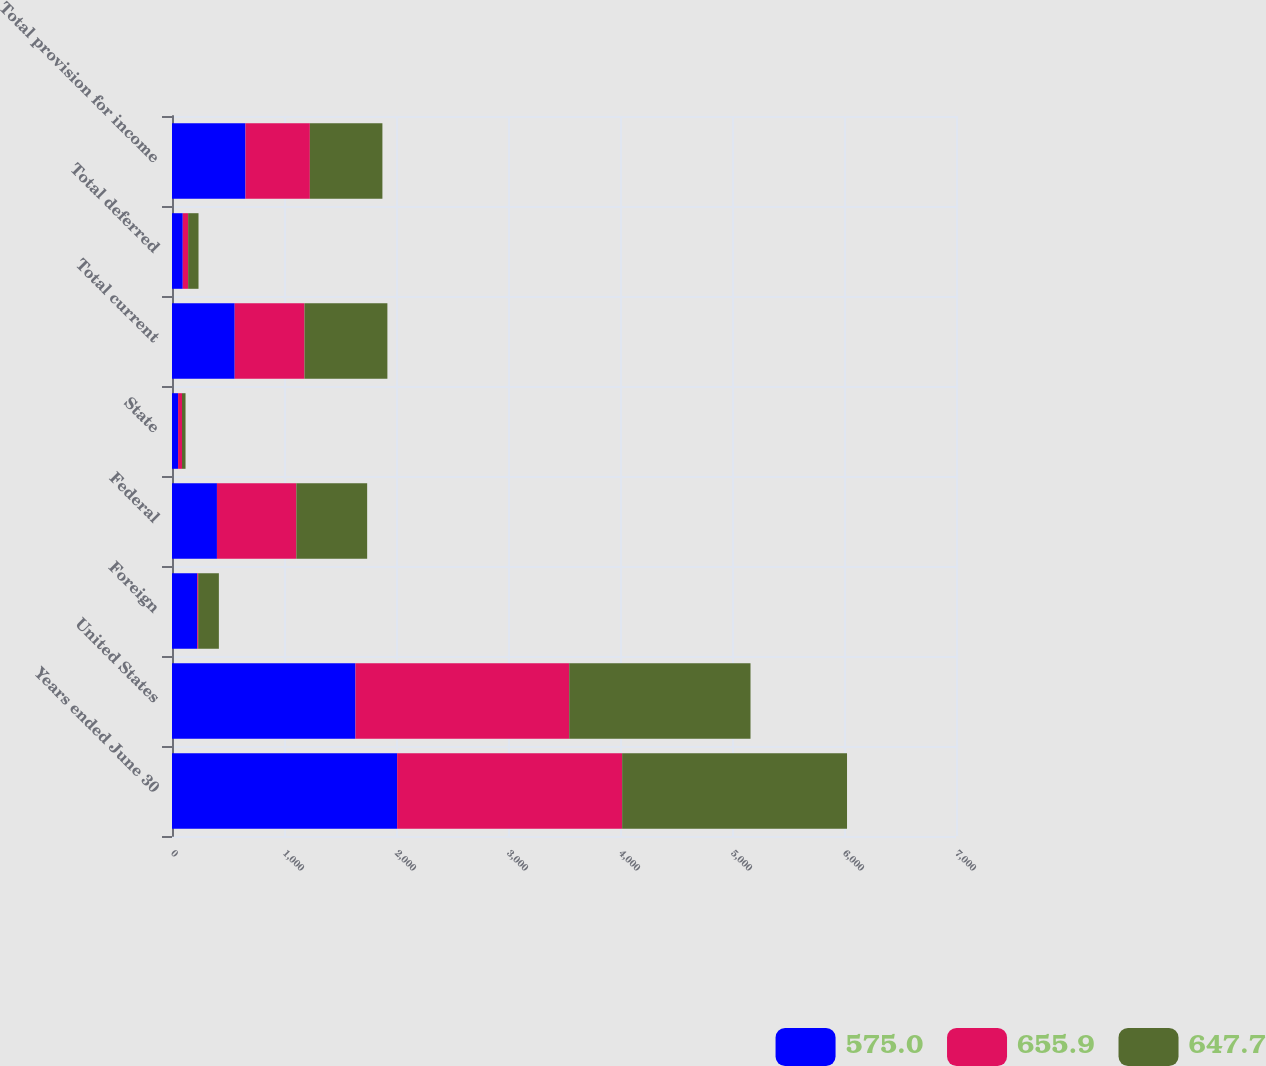Convert chart. <chart><loc_0><loc_0><loc_500><loc_500><stacked_bar_chart><ecel><fcel>Years ended June 30<fcel>United States<fcel>Foreign<fcel>Federal<fcel>State<fcel>Total current<fcel>Total deferred<fcel>Total provision for income<nl><fcel>575<fcel>2010<fcel>1638<fcel>225.2<fcel>401.3<fcel>54.1<fcel>559.8<fcel>96.1<fcel>655.9<nl><fcel>655.9<fcel>2009<fcel>1908.6<fcel>8.5<fcel>708.9<fcel>35.2<fcel>622.9<fcel>47.9<fcel>575<nl><fcel>647.7<fcel>2008<fcel>1618.6<fcel>184.8<fcel>632.3<fcel>31.5<fcel>740.4<fcel>92.7<fcel>647.7<nl></chart> 